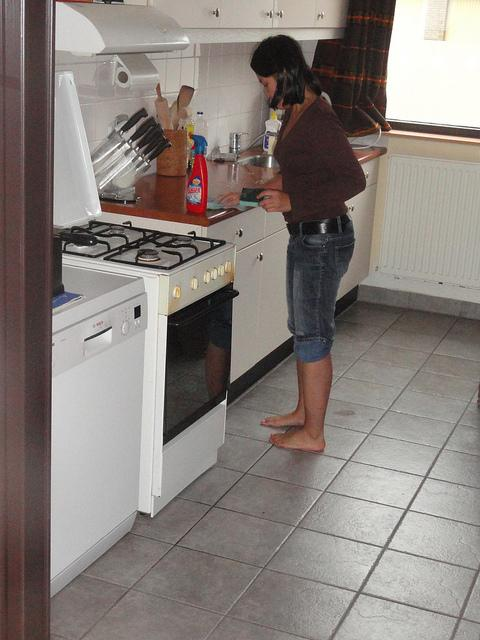What is the person doing in the kitchen? Please explain your reasoning. cleaning. The person has a rag in their hand. they are wiping the counter. 